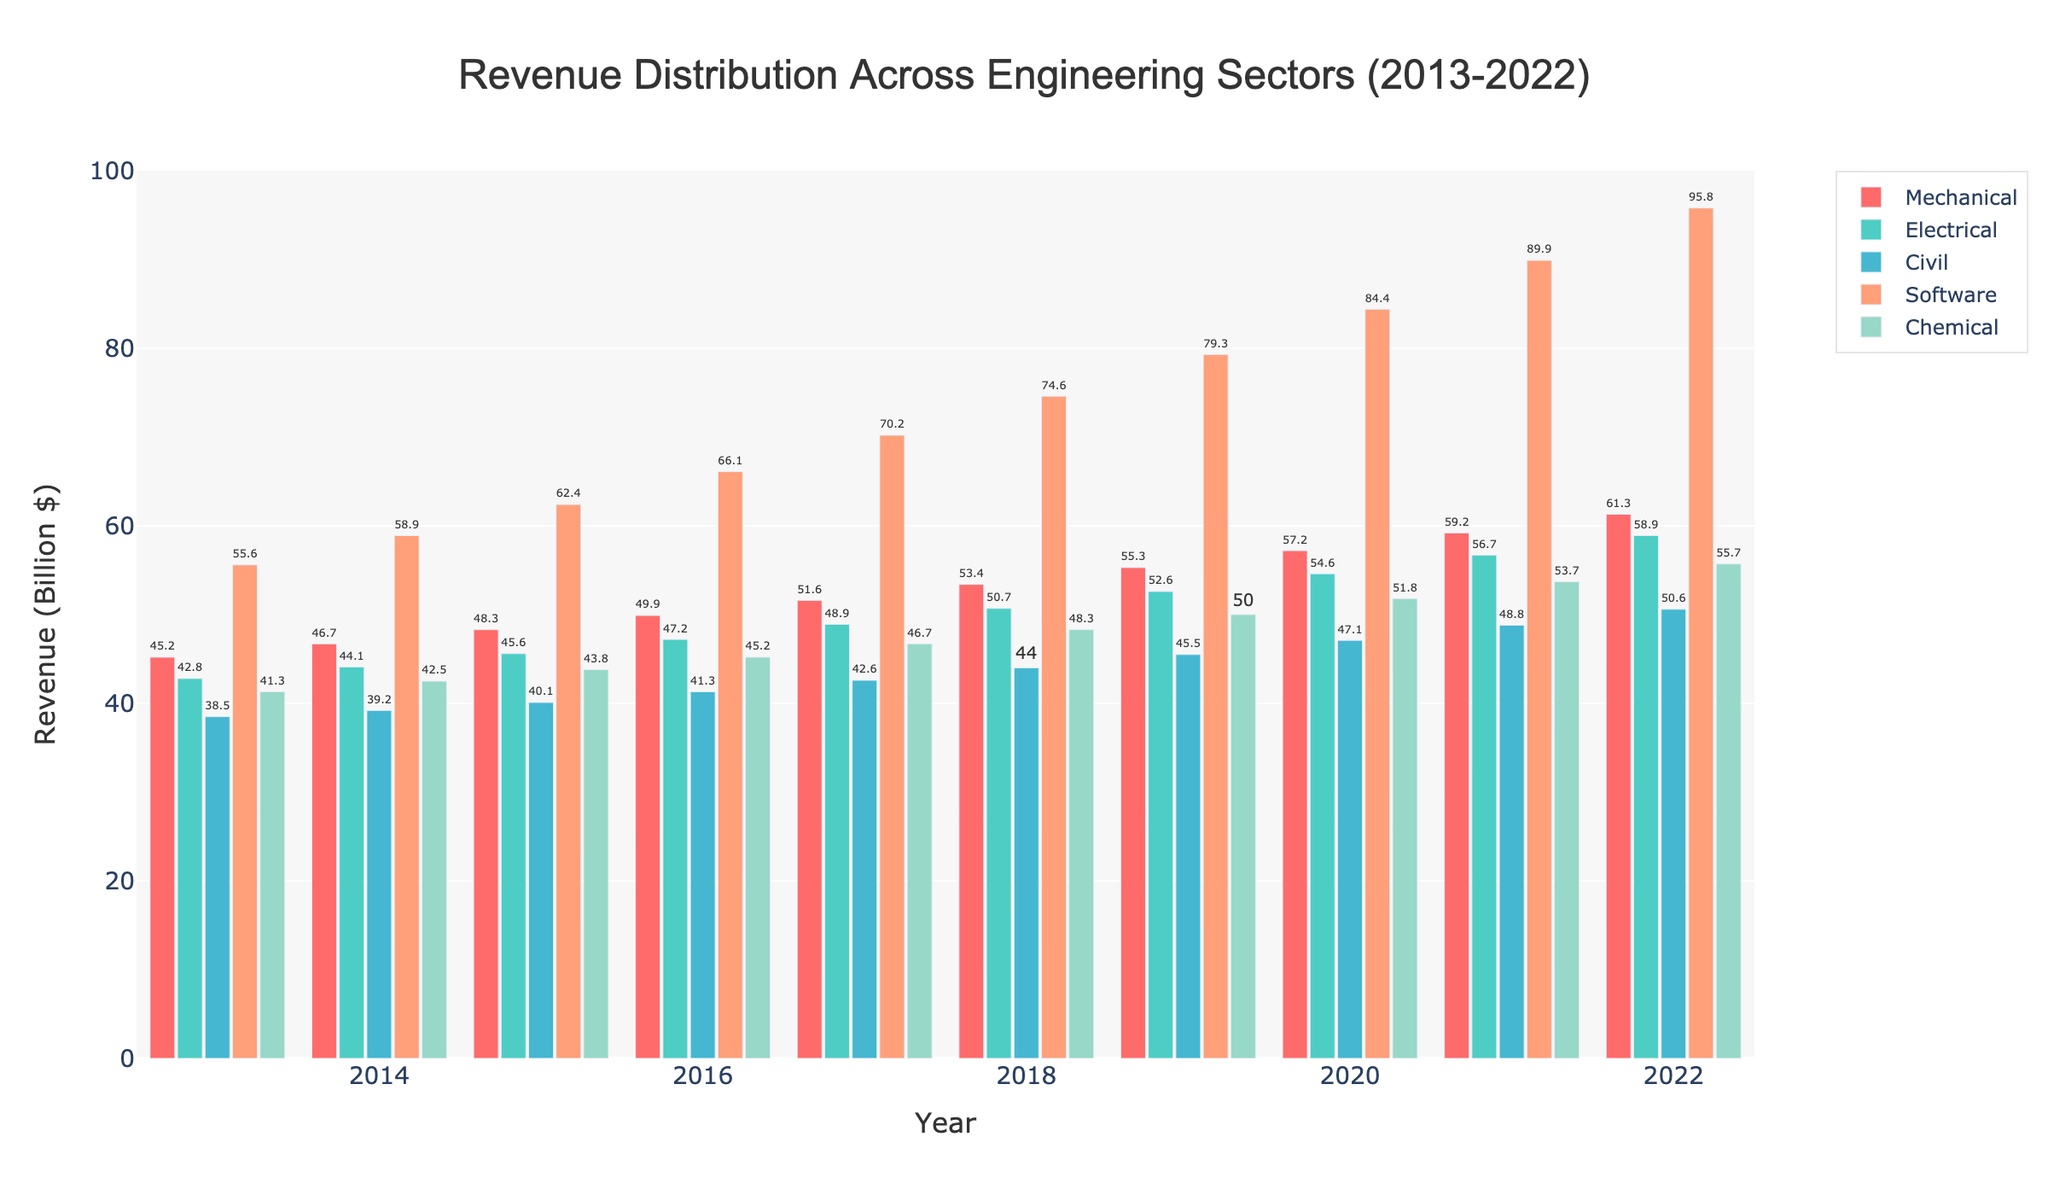What's the trend of revenue for the software sector from 2013 to 2022? The revenue for the software sector starts at 55.6 billion in 2013 and it increases every year, reaching 95.8 billion in 2022.
Answer: Increasing Which sector had the highest revenue in 2016? In 2016, the bar representing the software sector is the highest amongst all sectors.
Answer: Software What is the average annual revenue for the chemical sector over the entire period? Summing the revenues for the chemical sector for each year (41.3 + 42.5 + 43.8 + 45.2 + 46.7 + 48.3 + 50.0 + 51.8 + 53.7 + 55.7) equals 439, and there are 10 years. So, 439/10 = 43.9.
Answer: 43.9 billion In which year was the revenue for mechanical and civil sectors combined the highest? Adding the revenues for the mechanical and civil sectors for each year, the highest combined revenue is in 2022: 61.3 (mechanical) + 50.6 (civil) = 111.9.
Answer: 2022 Did the electrical sector ever surpass 50 billion in annual revenue? If so, in which year did it first occur? Looking at the heights of the bars for the electrical sector, it first exceeds 50 billion in 2018.
Answer: 2018 Between the civil and chemical sectors, which one had more consistent yearly growth in revenue? The bars for the chemical sector show a steady increase with relatively consistent increments, while the civil sector shows incremental growth but with smaller increases.
Answer: Chemical What was the difference in revenue between the highest and lowest sectors in 2020? The software sector had the highest revenue in 2020 at 84.4 billion, while the civil sector had the lowest at 47.1 billion. The difference is 84.4 - 47.1 = 37.3.
Answer: 37.3 billion Which sector experienced the fastest growth over the decade? By visual inspection, the software sector had the steepest increase from 55.6 billion in 2013 to 95.8 billion in 2022.
Answer: Software If you consider the sum of revenues for all sectors in 2017, what would be the total? Summing the revenues for all sectors in 2017 (51.6 + 48.9 + 42.6 + 70.2 + 46.7) equals 260.
Answer: 260 billion 